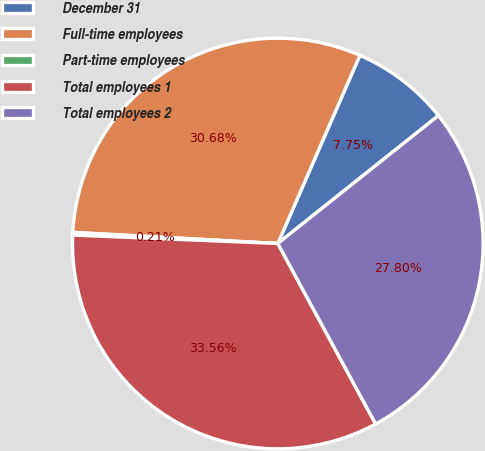Convert chart to OTSL. <chart><loc_0><loc_0><loc_500><loc_500><pie_chart><fcel>December 31<fcel>Full-time employees<fcel>Part-time employees<fcel>Total employees 1<fcel>Total employees 2<nl><fcel>7.75%<fcel>30.68%<fcel>0.21%<fcel>33.56%<fcel>27.8%<nl></chart> 